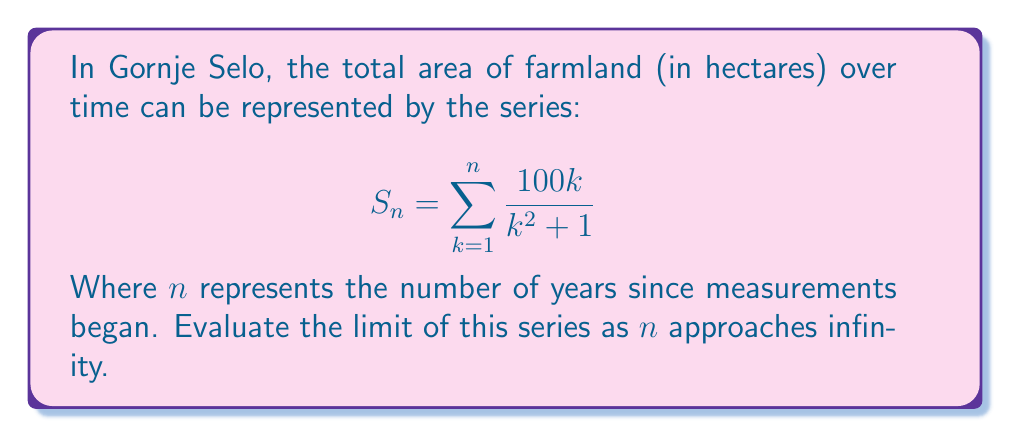Provide a solution to this math problem. To evaluate the limit of this series, we'll follow these steps:

1) First, let's examine the general term of the series:
   $$a_k = \frac{100k}{k^2 + 1}$$

2) To determine if the series converges, we can use the limit comparison test with $\frac{1}{k}$:

   $$\lim_{k \to \infty} \frac{a_k}{\frac{1}{k}} = \lim_{k \to \infty} \frac{100k}{k^2 + 1} \cdot k = \lim_{k \to \infty} \frac{100k^2}{k^2 + 1} = 100$$

3) Since this limit is a non-zero constant, our series converges if and only if $\sum \frac{1}{k}$ converges. However, $\sum \frac{1}{k}$ is the harmonic series, which diverges.

4) Therefore, our original series also diverges.

5) As $n$ approaches infinity, the sum will grow without bound.

Thus, the limit of the series as $n$ approaches infinity does not exist, and the total area of farmland in Gornje Selo, according to this model, would grow indefinitely over time.
Answer: The series diverges; the limit does not exist. 